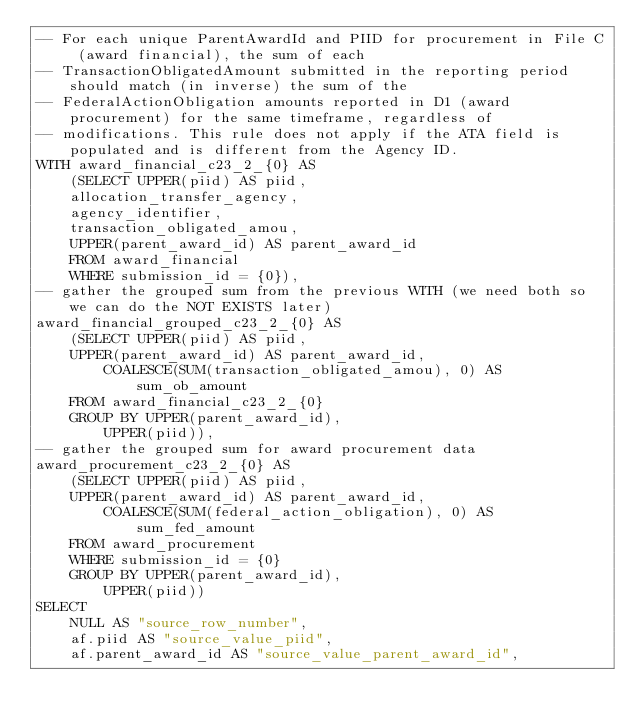<code> <loc_0><loc_0><loc_500><loc_500><_SQL_>-- For each unique ParentAwardId and PIID for procurement in File C (award financial), the sum of each
-- TransactionObligatedAmount submitted in the reporting period should match (in inverse) the sum of the
-- FederalActionObligation amounts reported in D1 (award procurement) for the same timeframe, regardless of
-- modifications. This rule does not apply if the ATA field is populated and is different from the Agency ID.
WITH award_financial_c23_2_{0} AS
    (SELECT UPPER(piid) AS piid,
    allocation_transfer_agency,
    agency_identifier,
    transaction_obligated_amou,
    UPPER(parent_award_id) AS parent_award_id
    FROM award_financial
    WHERE submission_id = {0}),
-- gather the grouped sum from the previous WITH (we need both so we can do the NOT EXISTS later)
award_financial_grouped_c23_2_{0} AS
    (SELECT UPPER(piid) AS piid,
    UPPER(parent_award_id) AS parent_award_id,
        COALESCE(SUM(transaction_obligated_amou), 0) AS sum_ob_amount
    FROM award_financial_c23_2_{0}
    GROUP BY UPPER(parent_award_id),
        UPPER(piid)),
-- gather the grouped sum for award procurement data
award_procurement_c23_2_{0} AS
    (SELECT UPPER(piid) AS piid,
    UPPER(parent_award_id) AS parent_award_id,
        COALESCE(SUM(federal_action_obligation), 0) AS sum_fed_amount
    FROM award_procurement
    WHERE submission_id = {0}
    GROUP BY UPPER(parent_award_id),
        UPPER(piid))
SELECT
    NULL AS "source_row_number",
    af.piid AS "source_value_piid",
    af.parent_award_id AS "source_value_parent_award_id",</code> 